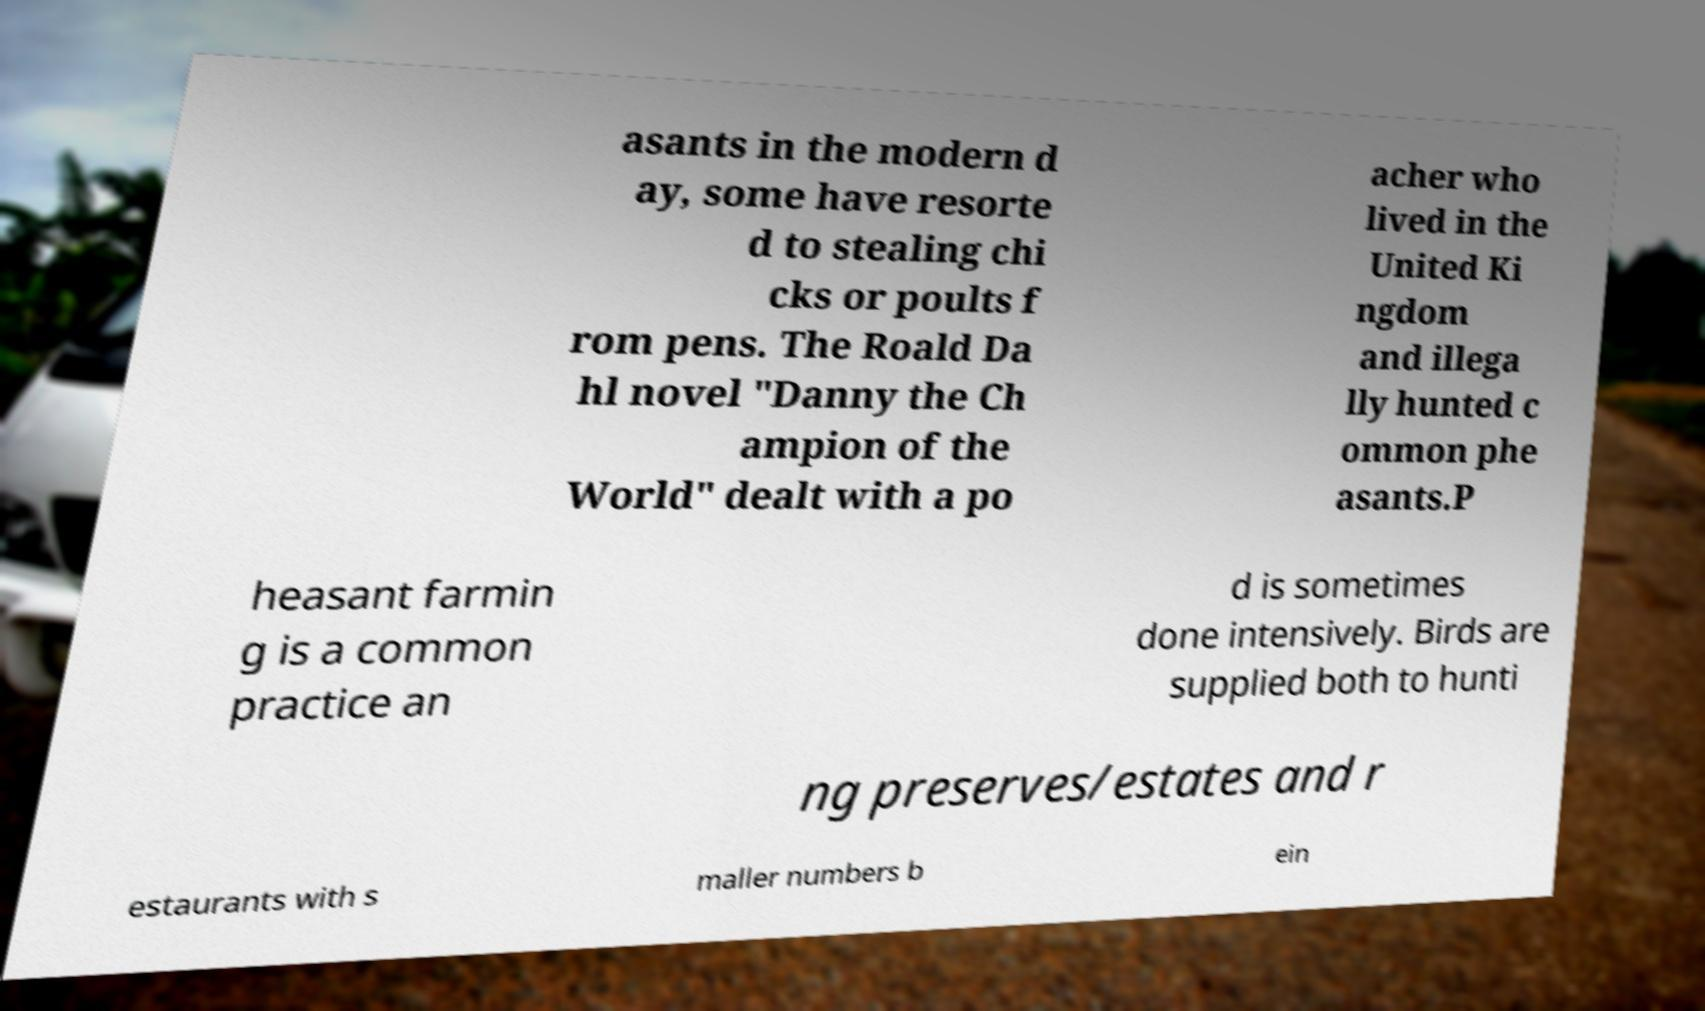Please read and relay the text visible in this image. What does it say? asants in the modern d ay, some have resorte d to stealing chi cks or poults f rom pens. The Roald Da hl novel "Danny the Ch ampion of the World" dealt with a po acher who lived in the United Ki ngdom and illega lly hunted c ommon phe asants.P heasant farmin g is a common practice an d is sometimes done intensively. Birds are supplied both to hunti ng preserves/estates and r estaurants with s maller numbers b ein 